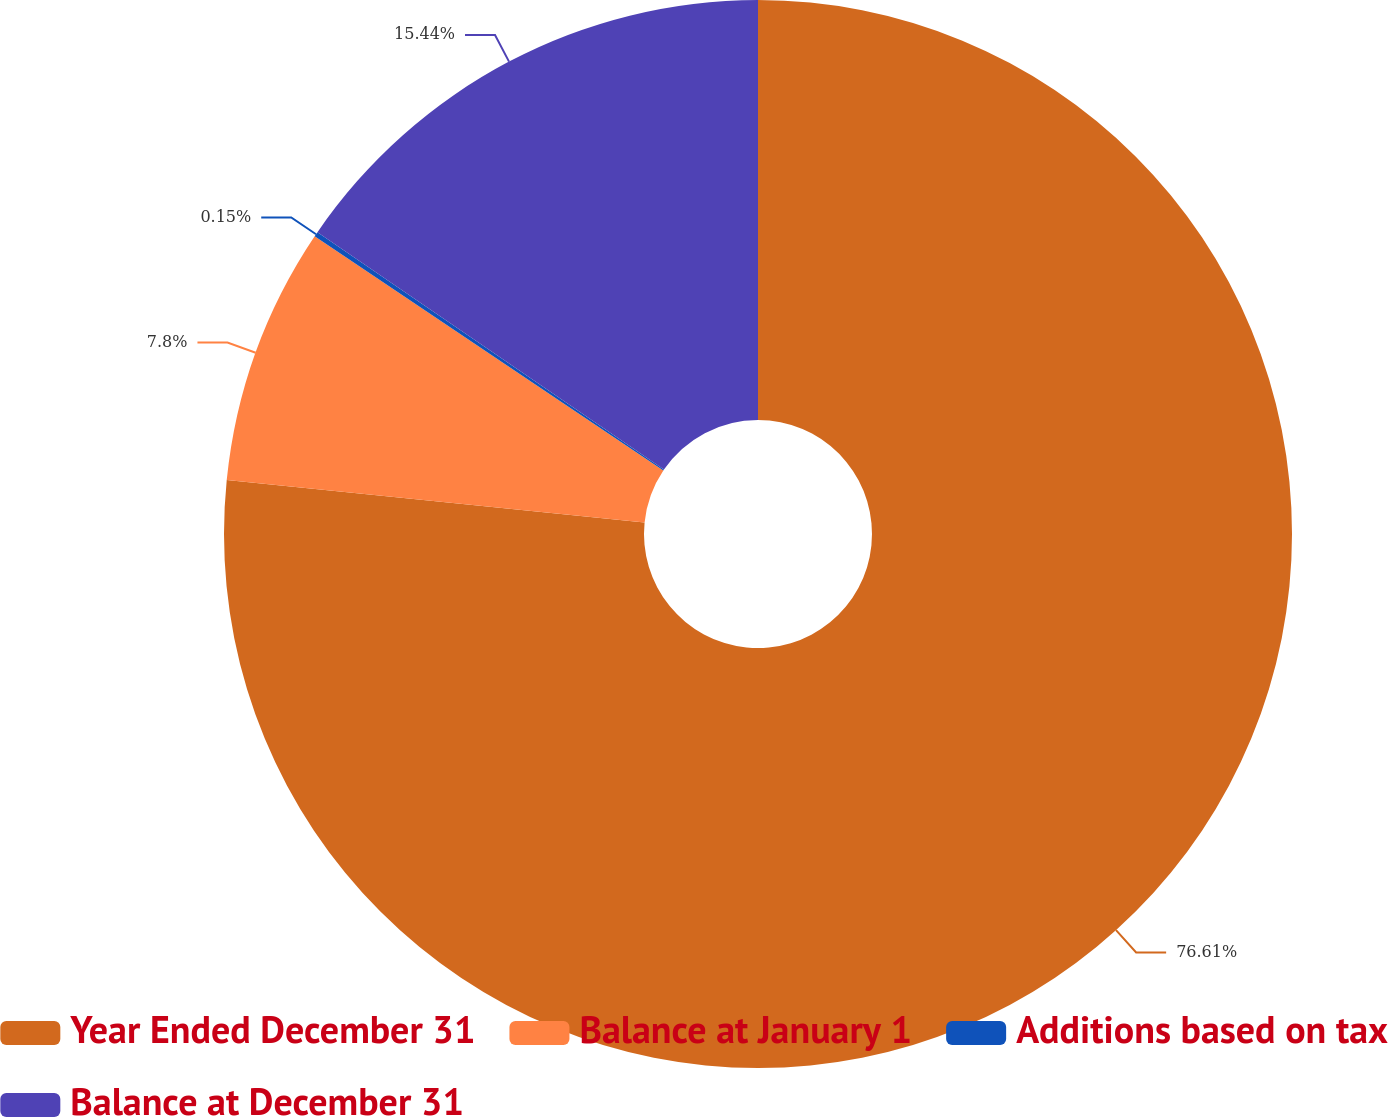Convert chart. <chart><loc_0><loc_0><loc_500><loc_500><pie_chart><fcel>Year Ended December 31<fcel>Balance at January 1<fcel>Additions based on tax<fcel>Balance at December 31<nl><fcel>76.61%<fcel>7.8%<fcel>0.15%<fcel>15.44%<nl></chart> 